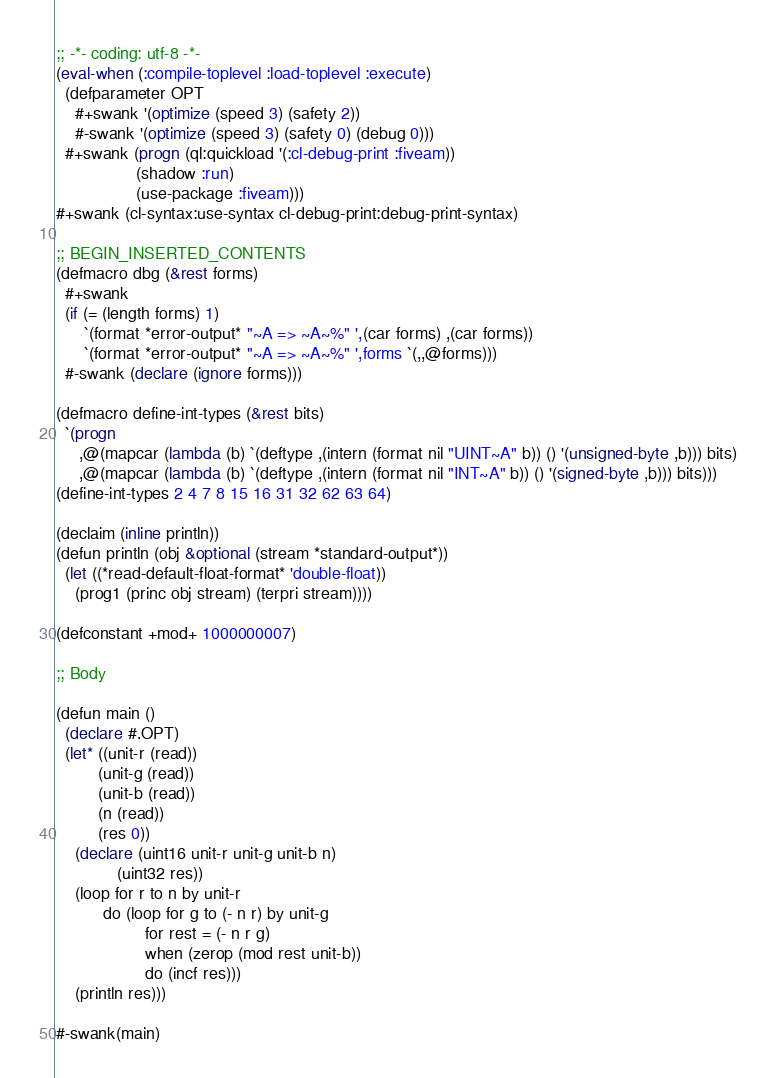Convert code to text. <code><loc_0><loc_0><loc_500><loc_500><_Lisp_>;; -*- coding: utf-8 -*-
(eval-when (:compile-toplevel :load-toplevel :execute)
  (defparameter OPT
    #+swank '(optimize (speed 3) (safety 2))
    #-swank '(optimize (speed 3) (safety 0) (debug 0)))
  #+swank (progn (ql:quickload '(:cl-debug-print :fiveam))
                 (shadow :run)
                 (use-package :fiveam)))
#+swank (cl-syntax:use-syntax cl-debug-print:debug-print-syntax)

;; BEGIN_INSERTED_CONTENTS
(defmacro dbg (&rest forms)
  #+swank
  (if (= (length forms) 1)
      `(format *error-output* "~A => ~A~%" ',(car forms) ,(car forms))
      `(format *error-output* "~A => ~A~%" ',forms `(,,@forms)))
  #-swank (declare (ignore forms)))

(defmacro define-int-types (&rest bits)
  `(progn
     ,@(mapcar (lambda (b) `(deftype ,(intern (format nil "UINT~A" b)) () '(unsigned-byte ,b))) bits)
     ,@(mapcar (lambda (b) `(deftype ,(intern (format nil "INT~A" b)) () '(signed-byte ,b))) bits)))
(define-int-types 2 4 7 8 15 16 31 32 62 63 64)

(declaim (inline println))
(defun println (obj &optional (stream *standard-output*))
  (let ((*read-default-float-format* 'double-float))
    (prog1 (princ obj stream) (terpri stream))))

(defconstant +mod+ 1000000007)

;; Body

(defun main ()
  (declare #.OPT)
  (let* ((unit-r (read))
         (unit-g (read))
         (unit-b (read))
         (n (read))
         (res 0))
    (declare (uint16 unit-r unit-g unit-b n)
             (uint32 res))
    (loop for r to n by unit-r
          do (loop for g to (- n r) by unit-g
                   for rest = (- n r g)
                   when (zerop (mod rest unit-b))
                   do (incf res)))
    (println res)))
 
#-swank(main)
</code> 